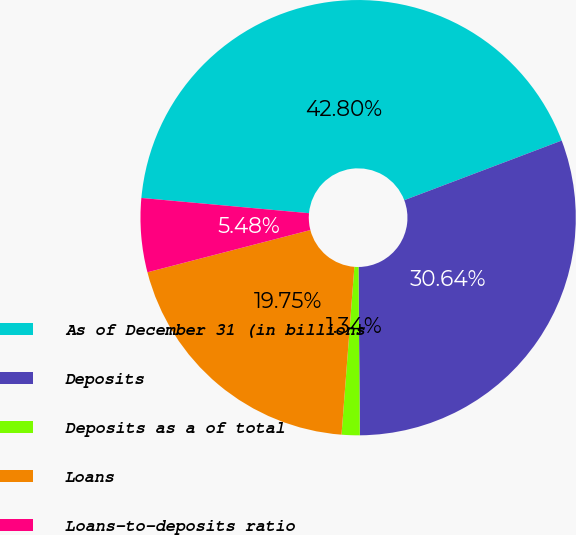<chart> <loc_0><loc_0><loc_500><loc_500><pie_chart><fcel>As of December 31 (in billions<fcel>Deposits<fcel>Deposits as a of total<fcel>Loans<fcel>Loans-to-deposits ratio<nl><fcel>42.8%<fcel>30.64%<fcel>1.34%<fcel>19.75%<fcel>5.48%<nl></chart> 